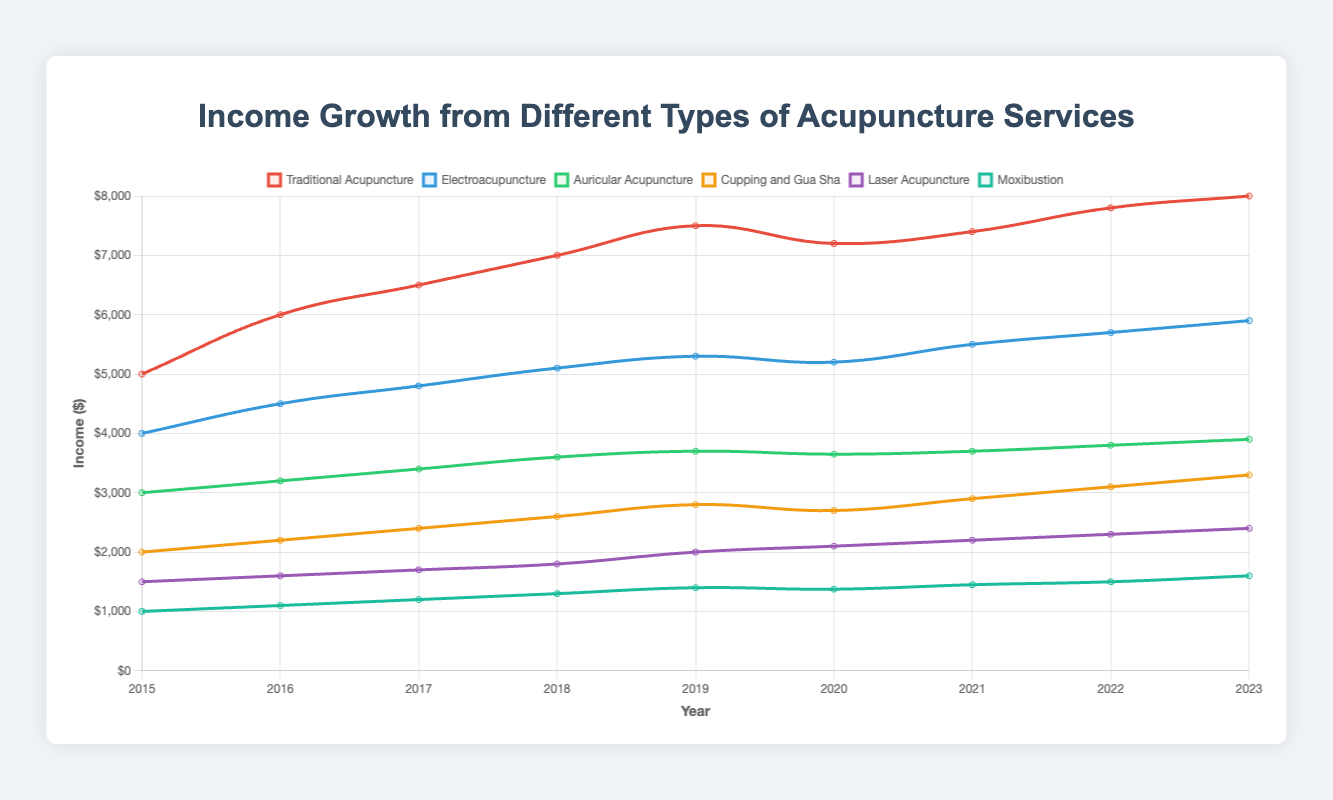Which service experienced the highest income in 2023? By looking at the endpoints of the lines on the chart for 2023, the Traditional Acupuncture line is the highest at $8000.
Answer: Traditional Acupuncture Which year did Electroacupuncture experience a drop in income growth? By following the Electroacupuncture line (blue) year by year, a drop can be seen from 2019 to 2020, decreasing from $5300 to $5200.
Answer: 2020 What is the total income generated by Cupping and Gua Sha from 2015 to 2023? The income values for Cupping and Gua Sha are given each year. Summing them up: 2000 + 2200 + 2400 + 2600 + 2800 + 2700 + 2900 + 3100 + 3300 = 24000.
Answer: 24000 Which acupuncture service had the least income growth between 2015 and 2023? By comparing the income differences from 2015 to 2023 for each service, Moxibustion grew from 1000 to 1600, which is the least increase of 600.
Answer: Moxibustion Did any service show a decrease in income from 2020 to 2021? Reviewing each line between 2020 and 2021, all lines either rise or stay the same. There was no decrease for any service.
Answer: No Which year showed the highest combined income across all services? Calculate the combined income for each year, and compare. 2020's combined income is highest: 
(Traditional: 7200) + (Electroacupuncture: 5200) + (Auricular: 3650) + (Cupping and Gua Sha: 2700) + (Laser: 2100) + (Moxibustion: 1375) = 22225, higher than other years.
Answer: 2020 How much more income did Traditional Acupuncture generate than Laser Acupuncture in 2023? The income for Traditional Acupuncture in 2023 is $8000. Laser Acupuncture in 2023 is $2400. The difference: $8000 - $2400 = $5600.
Answer: 5600 Which year did Traditional Acupuncture show the highest rate of growth from the previous year? Calculate the rate of growth each year for Traditional Acupuncture by finding yearly differences and dividing by previous year’s income. The highest growth rate is from 2015 to 2016: (6000 - 5000) / 5000 = 0.20 or 20%.
Answer: 2016 